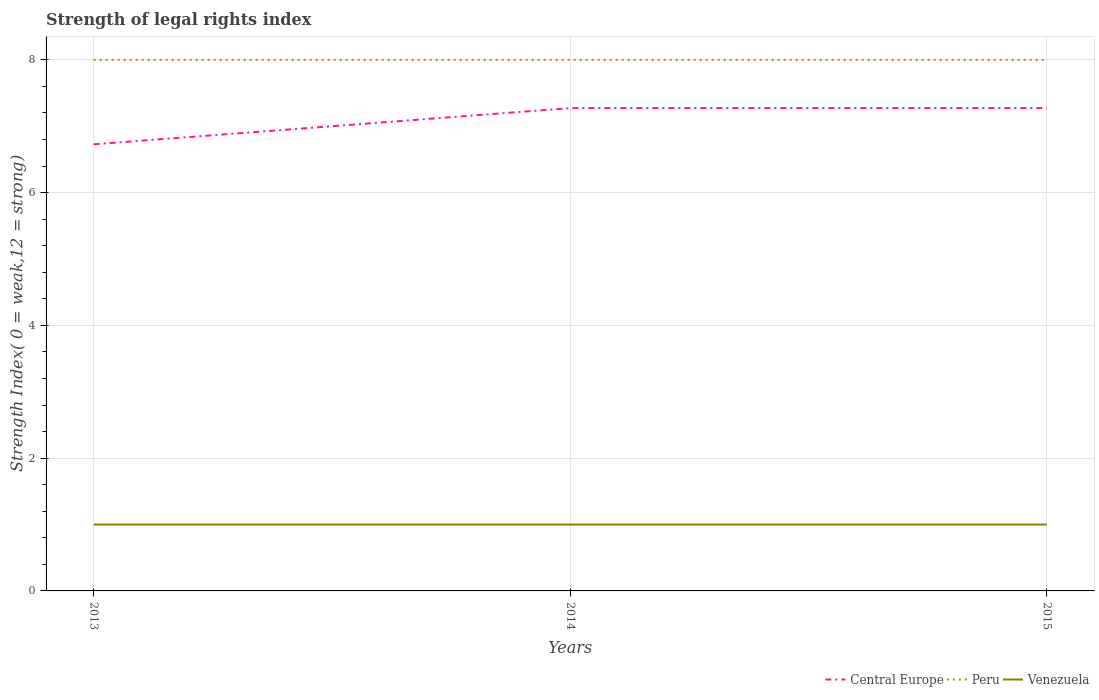How many different coloured lines are there?
Provide a short and direct response. 3. Does the line corresponding to Venezuela intersect with the line corresponding to Peru?
Your answer should be very brief. No. Is the number of lines equal to the number of legend labels?
Provide a succinct answer. Yes. Across all years, what is the maximum strength index in Venezuela?
Offer a very short reply. 1. What is the total strength index in Peru in the graph?
Offer a very short reply. 0. Is the strength index in Central Europe strictly greater than the strength index in Venezuela over the years?
Give a very brief answer. No. What is the difference between two consecutive major ticks on the Y-axis?
Ensure brevity in your answer.  2. Does the graph contain any zero values?
Give a very brief answer. No. Does the graph contain grids?
Provide a short and direct response. Yes. How are the legend labels stacked?
Provide a succinct answer. Horizontal. What is the title of the graph?
Offer a very short reply. Strength of legal rights index. What is the label or title of the X-axis?
Your answer should be compact. Years. What is the label or title of the Y-axis?
Ensure brevity in your answer.  Strength Index( 0 = weak,12 = strong). What is the Strength Index( 0 = weak,12 = strong) in Central Europe in 2013?
Keep it short and to the point. 6.73. What is the Strength Index( 0 = weak,12 = strong) of Central Europe in 2014?
Make the answer very short. 7.27. What is the Strength Index( 0 = weak,12 = strong) in Venezuela in 2014?
Keep it short and to the point. 1. What is the Strength Index( 0 = weak,12 = strong) in Central Europe in 2015?
Offer a terse response. 7.27. Across all years, what is the maximum Strength Index( 0 = weak,12 = strong) of Central Europe?
Keep it short and to the point. 7.27. Across all years, what is the maximum Strength Index( 0 = weak,12 = strong) of Peru?
Provide a succinct answer. 8. Across all years, what is the maximum Strength Index( 0 = weak,12 = strong) of Venezuela?
Keep it short and to the point. 1. Across all years, what is the minimum Strength Index( 0 = weak,12 = strong) of Central Europe?
Offer a very short reply. 6.73. Across all years, what is the minimum Strength Index( 0 = weak,12 = strong) in Venezuela?
Keep it short and to the point. 1. What is the total Strength Index( 0 = weak,12 = strong) in Central Europe in the graph?
Keep it short and to the point. 21.27. What is the total Strength Index( 0 = weak,12 = strong) in Peru in the graph?
Keep it short and to the point. 24. What is the total Strength Index( 0 = weak,12 = strong) of Venezuela in the graph?
Keep it short and to the point. 3. What is the difference between the Strength Index( 0 = weak,12 = strong) in Central Europe in 2013 and that in 2014?
Your response must be concise. -0.55. What is the difference between the Strength Index( 0 = weak,12 = strong) of Venezuela in 2013 and that in 2014?
Your answer should be compact. 0. What is the difference between the Strength Index( 0 = weak,12 = strong) of Central Europe in 2013 and that in 2015?
Your answer should be compact. -0.55. What is the difference between the Strength Index( 0 = weak,12 = strong) of Venezuela in 2013 and that in 2015?
Provide a succinct answer. 0. What is the difference between the Strength Index( 0 = weak,12 = strong) of Peru in 2014 and that in 2015?
Offer a very short reply. 0. What is the difference between the Strength Index( 0 = weak,12 = strong) of Central Europe in 2013 and the Strength Index( 0 = weak,12 = strong) of Peru in 2014?
Your response must be concise. -1.27. What is the difference between the Strength Index( 0 = weak,12 = strong) of Central Europe in 2013 and the Strength Index( 0 = weak,12 = strong) of Venezuela in 2014?
Provide a short and direct response. 5.73. What is the difference between the Strength Index( 0 = weak,12 = strong) of Peru in 2013 and the Strength Index( 0 = weak,12 = strong) of Venezuela in 2014?
Make the answer very short. 7. What is the difference between the Strength Index( 0 = weak,12 = strong) of Central Europe in 2013 and the Strength Index( 0 = weak,12 = strong) of Peru in 2015?
Your answer should be compact. -1.27. What is the difference between the Strength Index( 0 = weak,12 = strong) in Central Europe in 2013 and the Strength Index( 0 = weak,12 = strong) in Venezuela in 2015?
Give a very brief answer. 5.73. What is the difference between the Strength Index( 0 = weak,12 = strong) in Central Europe in 2014 and the Strength Index( 0 = weak,12 = strong) in Peru in 2015?
Your answer should be very brief. -0.73. What is the difference between the Strength Index( 0 = weak,12 = strong) in Central Europe in 2014 and the Strength Index( 0 = weak,12 = strong) in Venezuela in 2015?
Provide a short and direct response. 6.27. What is the average Strength Index( 0 = weak,12 = strong) in Central Europe per year?
Your answer should be compact. 7.09. What is the average Strength Index( 0 = weak,12 = strong) of Venezuela per year?
Ensure brevity in your answer.  1. In the year 2013, what is the difference between the Strength Index( 0 = weak,12 = strong) in Central Europe and Strength Index( 0 = weak,12 = strong) in Peru?
Your answer should be very brief. -1.27. In the year 2013, what is the difference between the Strength Index( 0 = weak,12 = strong) in Central Europe and Strength Index( 0 = weak,12 = strong) in Venezuela?
Keep it short and to the point. 5.73. In the year 2014, what is the difference between the Strength Index( 0 = weak,12 = strong) in Central Europe and Strength Index( 0 = weak,12 = strong) in Peru?
Your answer should be compact. -0.73. In the year 2014, what is the difference between the Strength Index( 0 = weak,12 = strong) of Central Europe and Strength Index( 0 = weak,12 = strong) of Venezuela?
Provide a succinct answer. 6.27. In the year 2015, what is the difference between the Strength Index( 0 = weak,12 = strong) of Central Europe and Strength Index( 0 = weak,12 = strong) of Peru?
Make the answer very short. -0.73. In the year 2015, what is the difference between the Strength Index( 0 = weak,12 = strong) in Central Europe and Strength Index( 0 = weak,12 = strong) in Venezuela?
Give a very brief answer. 6.27. What is the ratio of the Strength Index( 0 = weak,12 = strong) in Central Europe in 2013 to that in 2014?
Ensure brevity in your answer.  0.93. What is the ratio of the Strength Index( 0 = weak,12 = strong) of Central Europe in 2013 to that in 2015?
Ensure brevity in your answer.  0.93. What is the ratio of the Strength Index( 0 = weak,12 = strong) of Venezuela in 2013 to that in 2015?
Provide a short and direct response. 1. What is the ratio of the Strength Index( 0 = weak,12 = strong) in Central Europe in 2014 to that in 2015?
Your answer should be compact. 1. What is the difference between the highest and the second highest Strength Index( 0 = weak,12 = strong) in Central Europe?
Your response must be concise. 0. What is the difference between the highest and the second highest Strength Index( 0 = weak,12 = strong) of Peru?
Provide a succinct answer. 0. What is the difference between the highest and the lowest Strength Index( 0 = weak,12 = strong) of Central Europe?
Keep it short and to the point. 0.55. What is the difference between the highest and the lowest Strength Index( 0 = weak,12 = strong) in Peru?
Your answer should be compact. 0. What is the difference between the highest and the lowest Strength Index( 0 = weak,12 = strong) of Venezuela?
Offer a very short reply. 0. 